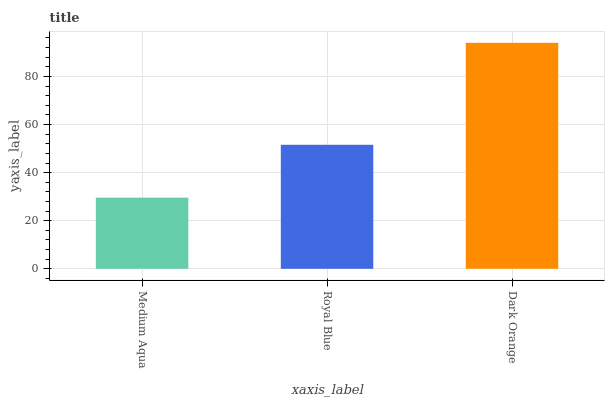Is Medium Aqua the minimum?
Answer yes or no. Yes. Is Dark Orange the maximum?
Answer yes or no. Yes. Is Royal Blue the minimum?
Answer yes or no. No. Is Royal Blue the maximum?
Answer yes or no. No. Is Royal Blue greater than Medium Aqua?
Answer yes or no. Yes. Is Medium Aqua less than Royal Blue?
Answer yes or no. Yes. Is Medium Aqua greater than Royal Blue?
Answer yes or no. No. Is Royal Blue less than Medium Aqua?
Answer yes or no. No. Is Royal Blue the high median?
Answer yes or no. Yes. Is Royal Blue the low median?
Answer yes or no. Yes. Is Medium Aqua the high median?
Answer yes or no. No. Is Medium Aqua the low median?
Answer yes or no. No. 